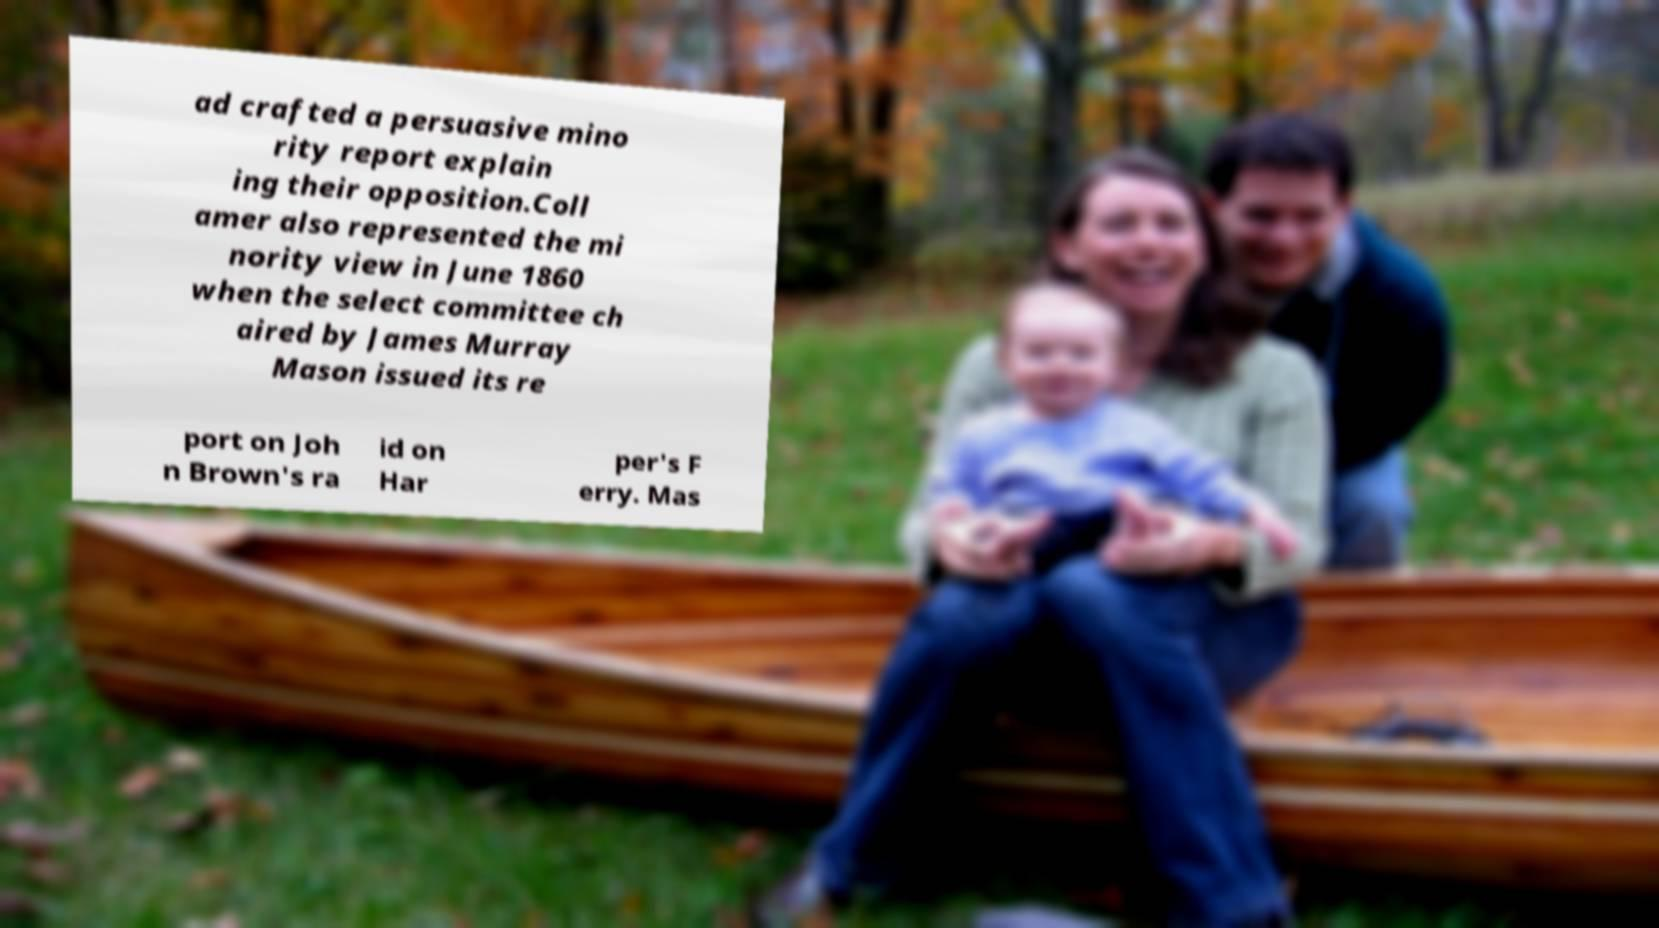There's text embedded in this image that I need extracted. Can you transcribe it verbatim? ad crafted a persuasive mino rity report explain ing their opposition.Coll amer also represented the mi nority view in June 1860 when the select committee ch aired by James Murray Mason issued its re port on Joh n Brown's ra id on Har per's F erry. Mas 